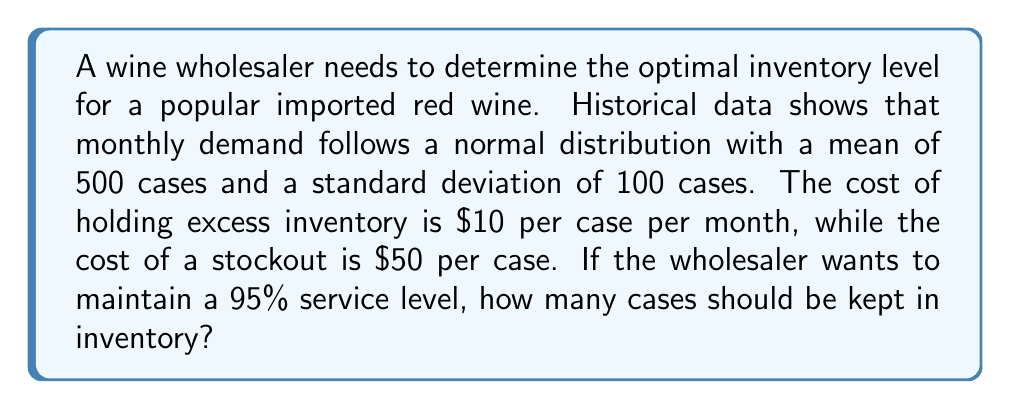What is the answer to this math problem? To solve this problem, we'll use the concept of the safety stock formula and the inverse normal distribution function.

Step 1: Determine the z-score for a 95% service level.
For a 95% service level, the z-score is 1.645 (from standard normal distribution tables).

Step 2: Calculate the safety stock using the formula:
$$ \text{Safety Stock} = z \times \sigma $$
Where $z$ is the z-score and $\sigma$ is the standard deviation of demand.

$$ \text{Safety Stock} = 1.645 \times 100 = 164.5 \text{ cases} $$

Step 3: Calculate the optimal inventory level by adding the safety stock to the mean demand:
$$ \text{Optimal Inventory} = \mu + \text{Safety Stock} $$
Where $\mu$ is the mean demand.

$$ \text{Optimal Inventory} = 500 + 164.5 = 664.5 \text{ cases} $$

Step 4: Round up to the nearest whole number, as we can't stock fractional cases.

$$ \text{Optimal Inventory} = 665 \text{ cases} $$

This inventory level will ensure a 95% service level, balancing the costs of holding excess inventory against the costs of stockouts.
Answer: 665 cases 